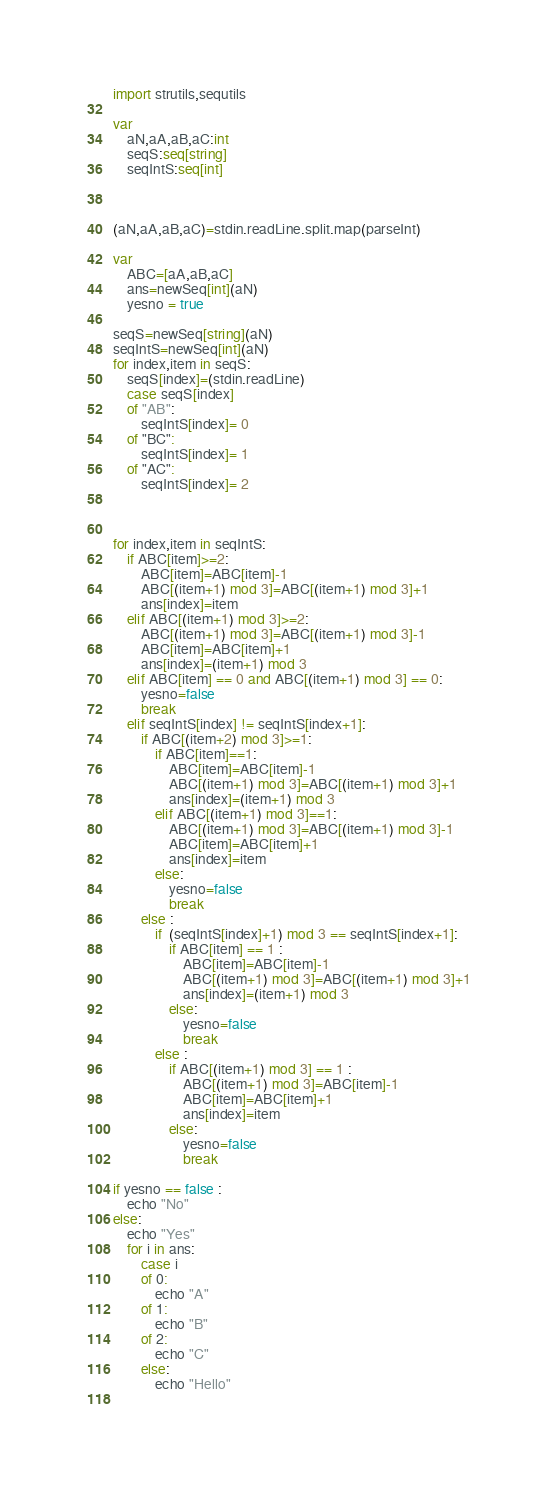<code> <loc_0><loc_0><loc_500><loc_500><_Nim_>import strutils,sequtils

var 
    aN,aA,aB,aC:int
    seqS:seq[string]
    seqIntS:seq[int]
    


(aN,aA,aB,aC)=stdin.readLine.split.map(parseInt)

var 
    ABC=[aA,aB,aC]
    ans=newSeq[int](aN)
    yesno = true

seqS=newSeq[string](aN)
seqIntS=newSeq[int](aN)
for index,item in seqS:
    seqS[index]=(stdin.readLine) 
    case seqS[index] 
    of "AB":
        seqIntS[index]= 0
    of "BC":
        seqIntS[index]= 1
    of "AC":
        seqIntS[index]= 2



for index,item in seqIntS:
    if ABC[item]>=2:
        ABC[item]=ABC[item]-1
        ABC[(item+1) mod 3]=ABC[(item+1) mod 3]+1
        ans[index]=item
    elif ABC[(item+1) mod 3]>=2:
        ABC[(item+1) mod 3]=ABC[(item+1) mod 3]-1
        ABC[item]=ABC[item]+1
        ans[index]=(item+1) mod 3
    elif ABC[item] == 0 and ABC[(item+1) mod 3] == 0:
        yesno=false
        break
    elif seqIntS[index] != seqIntS[index+1]:
        if ABC[(item+2) mod 3]>=1:
            if ABC[item]==1:
                ABC[item]=ABC[item]-1
                ABC[(item+1) mod 3]=ABC[(item+1) mod 3]+1
                ans[index]=(item+1) mod 3
            elif ABC[(item+1) mod 3]==1:
                ABC[(item+1) mod 3]=ABC[(item+1) mod 3]-1
                ABC[item]=ABC[item]+1
                ans[index]=item
            else:
                yesno=false
                break
        else :
            if  (seqIntS[index]+1) mod 3 == seqIntS[index+1]:
                if ABC[item] == 1 :
                    ABC[item]=ABC[item]-1
                    ABC[(item+1) mod 3]=ABC[(item+1) mod 3]+1
                    ans[index]=(item+1) mod 3
                else:
                    yesno=false
                    break
            else :
                if ABC[(item+1) mod 3] == 1 :
                    ABC[(item+1) mod 3]=ABC[item]-1
                    ABC[item]=ABC[item]+1
                    ans[index]=item
                else:
                    yesno=false
                    break

if yesno == false :
    echo "No"
else:
    echo "Yes"
    for i in ans:
        case i
        of 0:
            echo "A"
        of 1:
            echo "B"
        of 2:
            echo "C"
        else:
            echo "Hello"
            </code> 